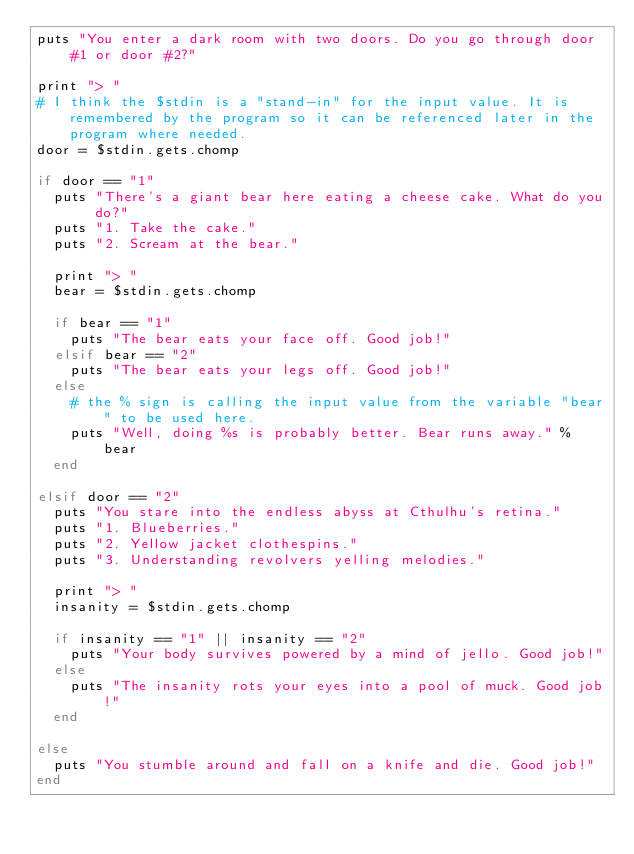Convert code to text. <code><loc_0><loc_0><loc_500><loc_500><_Ruby_>puts "You enter a dark room with two doors. Do you go through door #1 or door #2?"

print "> "
# I think the $stdin is a "stand-in" for the input value. It is remembered by the program so it can be referenced later in the program where needed.
door = $stdin.gets.chomp

if door == "1"
  puts "There's a giant bear here eating a cheese cake. What do you do?"
  puts "1. Take the cake."
  puts "2. Scream at the bear."

  print "> "
  bear = $stdin.gets.chomp

  if bear == "1"
    puts "The bear eats your face off. Good job!"
  elsif bear == "2"
    puts "The bear eats your legs off. Good job!"
  else
    # the % sign is calling the input value from the variable "bear" to be used here.
    puts "Well, doing %s is probably better. Bear runs away." % bear
  end

elsif door == "2"
  puts "You stare into the endless abyss at Cthulhu's retina."
  puts "1. Blueberries."
  puts "2. Yellow jacket clothespins."
  puts "3. Understanding revolvers yelling melodies."

  print "> "
  insanity = $stdin.gets.chomp

  if insanity == "1" || insanity == "2"
    puts "Your body survives powered by a mind of jello. Good job!"
  else
    puts "The insanity rots your eyes into a pool of muck. Good job!"
  end

else
  puts "You stumble around and fall on a knife and die. Good job!"
end
</code> 